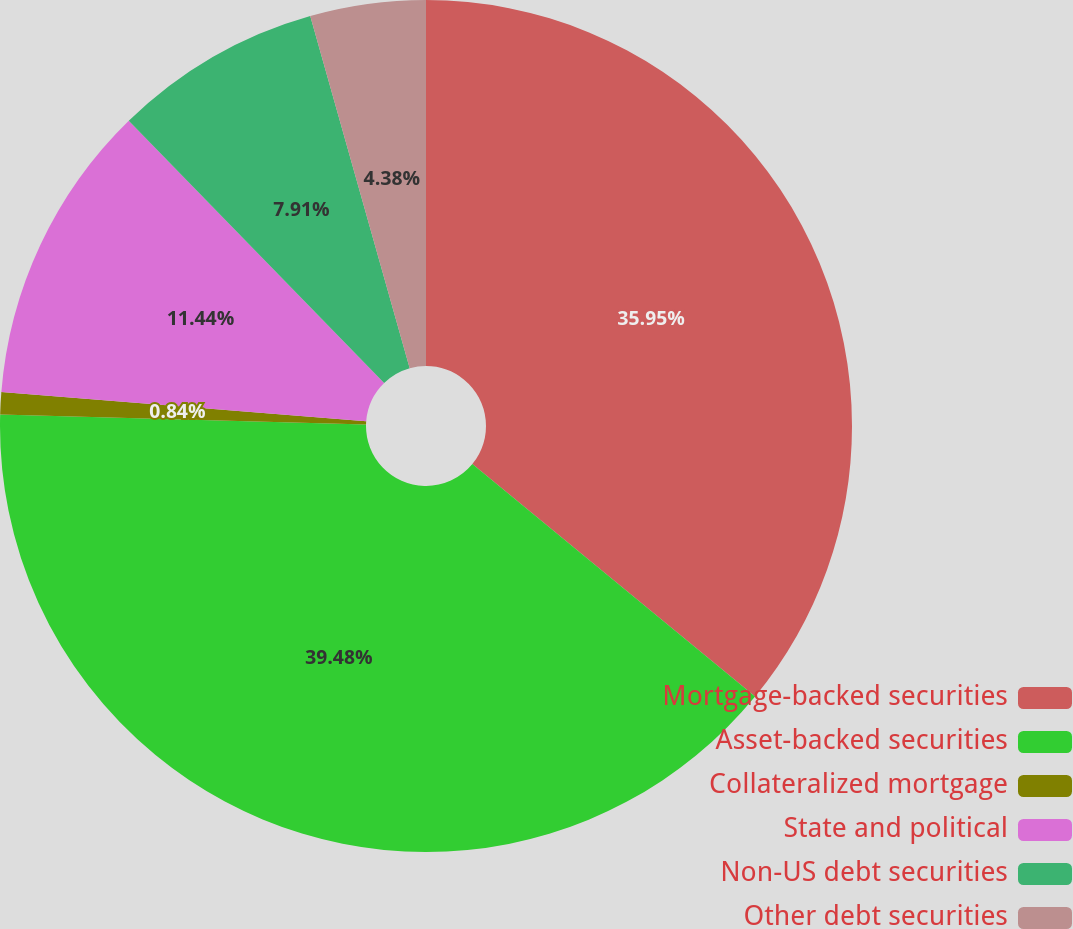<chart> <loc_0><loc_0><loc_500><loc_500><pie_chart><fcel>Mortgage-backed securities<fcel>Asset-backed securities<fcel>Collateralized mortgage<fcel>State and political<fcel>Non-US debt securities<fcel>Other debt securities<nl><fcel>35.95%<fcel>39.48%<fcel>0.84%<fcel>11.44%<fcel>7.91%<fcel>4.38%<nl></chart> 